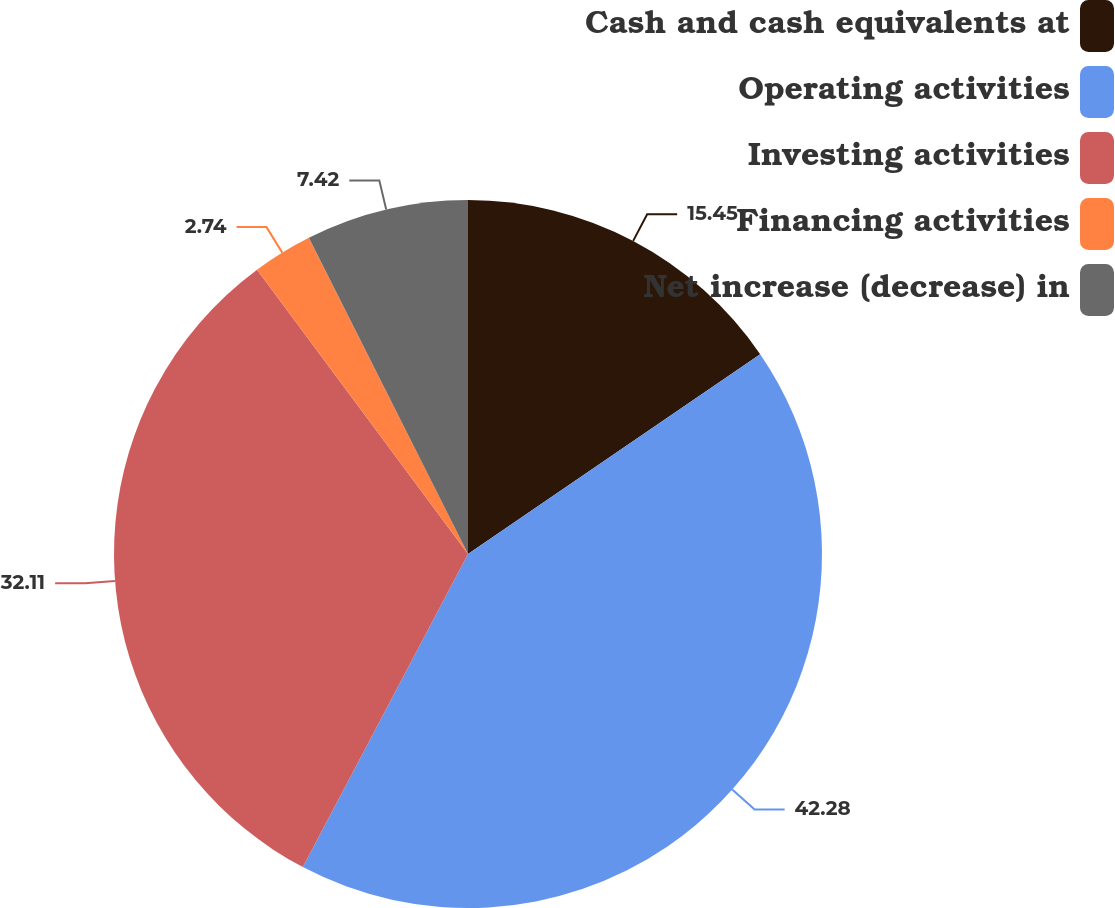<chart> <loc_0><loc_0><loc_500><loc_500><pie_chart><fcel>Cash and cash equivalents at<fcel>Operating activities<fcel>Investing activities<fcel>Financing activities<fcel>Net increase (decrease) in<nl><fcel>15.45%<fcel>42.27%<fcel>32.11%<fcel>2.74%<fcel>7.42%<nl></chart> 